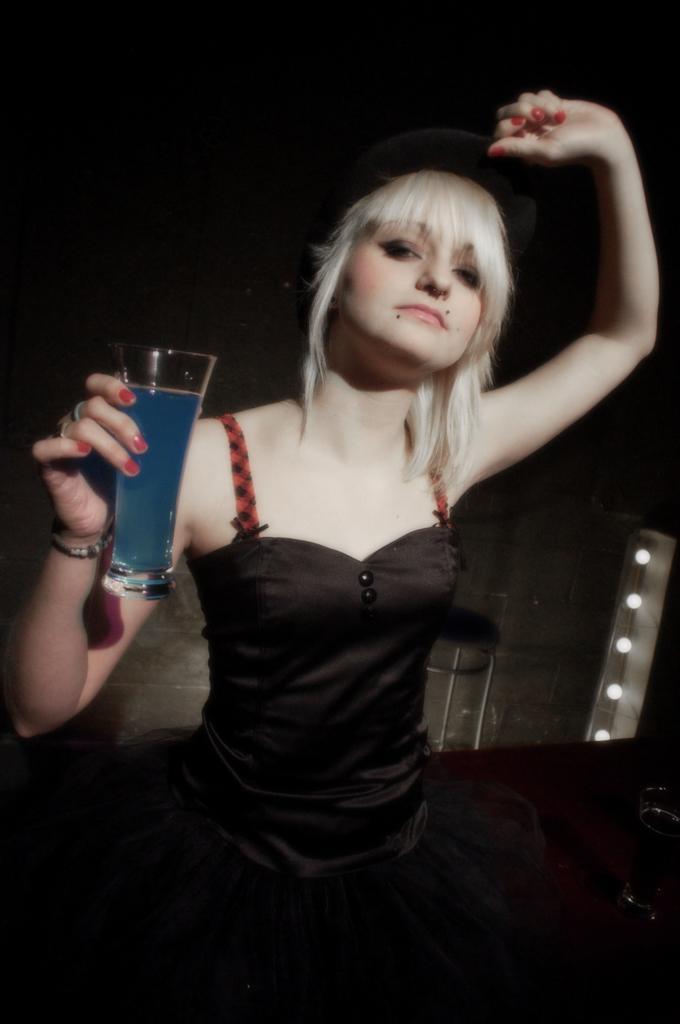How would you summarize this image in a sentence or two? In the middle of the image a woman is standing and holding a glass. Behind her there is wall. 